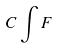Convert formula to latex. <formula><loc_0><loc_0><loc_500><loc_500>C \int F</formula> 